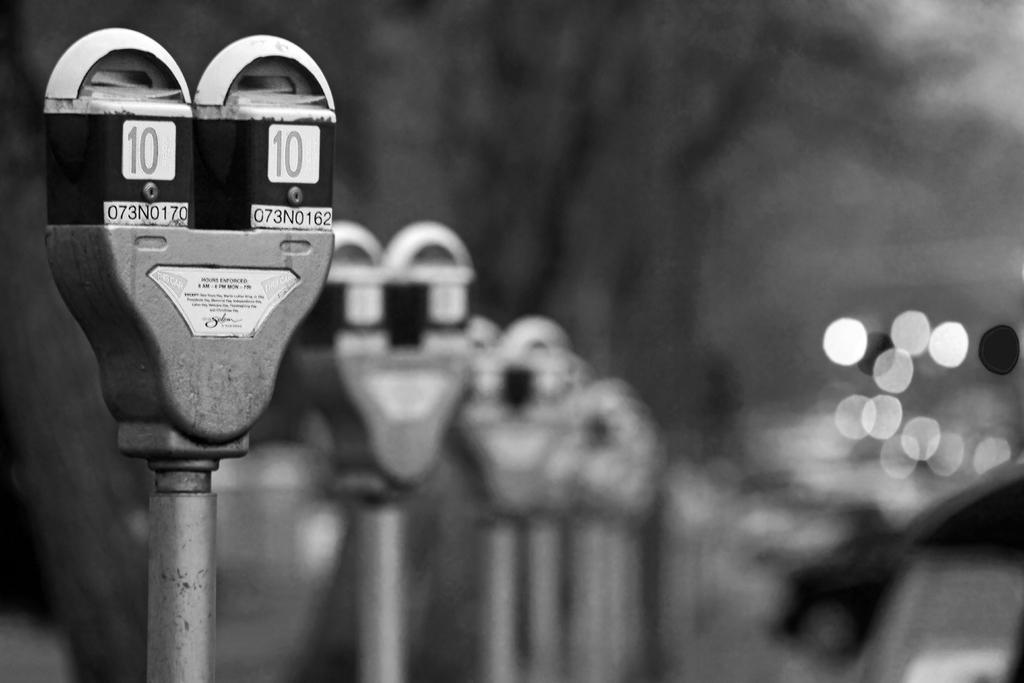<image>
Provide a brief description of the given image. Parking meter number 10 standing on a street in front of trees. 